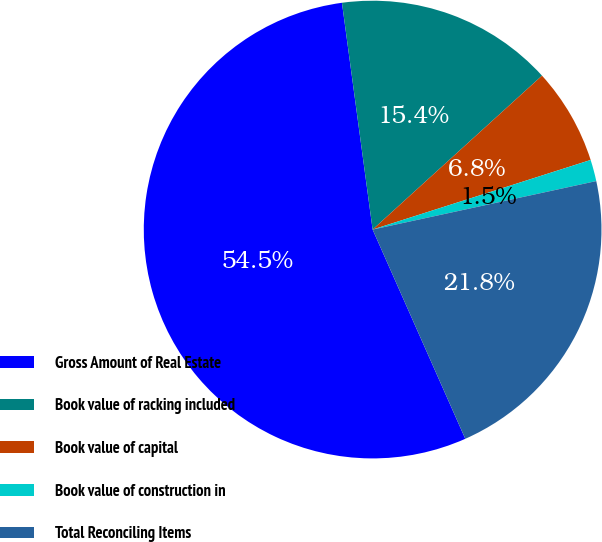Convert chart to OTSL. <chart><loc_0><loc_0><loc_500><loc_500><pie_chart><fcel>Gross Amount of Real Estate<fcel>Book value of racking included<fcel>Book value of capital<fcel>Book value of construction in<fcel>Total Reconciling Items<nl><fcel>54.49%<fcel>15.4%<fcel>6.82%<fcel>1.52%<fcel>21.76%<nl></chart> 